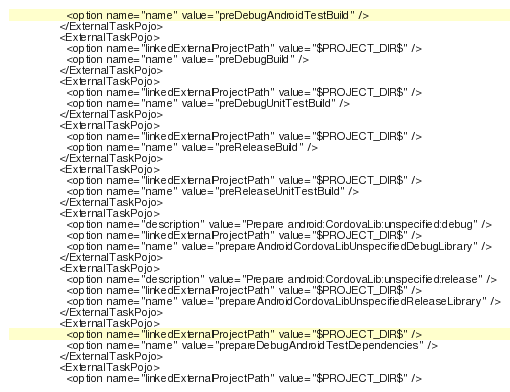<code> <loc_0><loc_0><loc_500><loc_500><_XML_>                <option name="name" value="preDebugAndroidTestBuild" />
              </ExternalTaskPojo>
              <ExternalTaskPojo>
                <option name="linkedExternalProjectPath" value="$PROJECT_DIR$" />
                <option name="name" value="preDebugBuild" />
              </ExternalTaskPojo>
              <ExternalTaskPojo>
                <option name="linkedExternalProjectPath" value="$PROJECT_DIR$" />
                <option name="name" value="preDebugUnitTestBuild" />
              </ExternalTaskPojo>
              <ExternalTaskPojo>
                <option name="linkedExternalProjectPath" value="$PROJECT_DIR$" />
                <option name="name" value="preReleaseBuild" />
              </ExternalTaskPojo>
              <ExternalTaskPojo>
                <option name="linkedExternalProjectPath" value="$PROJECT_DIR$" />
                <option name="name" value="preReleaseUnitTestBuild" />
              </ExternalTaskPojo>
              <ExternalTaskPojo>
                <option name="description" value="Prepare android:CordovaLib:unspecified:debug" />
                <option name="linkedExternalProjectPath" value="$PROJECT_DIR$" />
                <option name="name" value="prepareAndroidCordovaLibUnspecifiedDebugLibrary" />
              </ExternalTaskPojo>
              <ExternalTaskPojo>
                <option name="description" value="Prepare android:CordovaLib:unspecified:release" />
                <option name="linkedExternalProjectPath" value="$PROJECT_DIR$" />
                <option name="name" value="prepareAndroidCordovaLibUnspecifiedReleaseLibrary" />
              </ExternalTaskPojo>
              <ExternalTaskPojo>
                <option name="linkedExternalProjectPath" value="$PROJECT_DIR$" />
                <option name="name" value="prepareDebugAndroidTestDependencies" />
              </ExternalTaskPojo>
              <ExternalTaskPojo>
                <option name="linkedExternalProjectPath" value="$PROJECT_DIR$" /></code> 